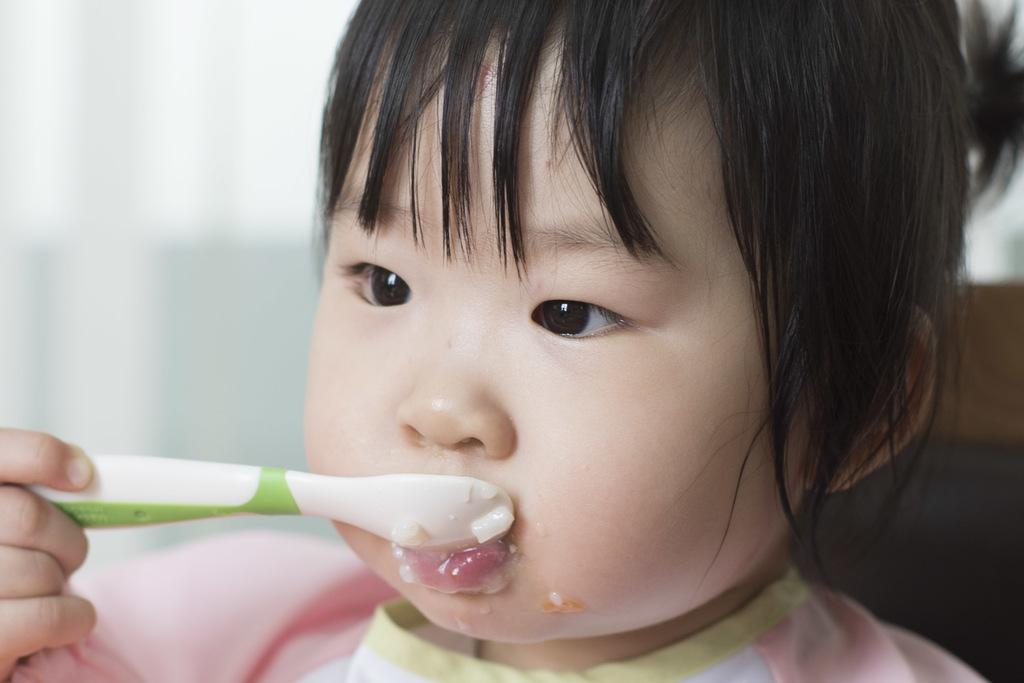What is the main subject of the image? There is a baby in the image. What is the baby doing in the image? The baby is eating food. What is the baby using to eat the food? The baby is holding a spoon in her hand. What can be seen in the background of the image? There is a wall visible in the background of the image. What type of current is flowing through the baby's hair in the image? There is no current present in the image; the baby's hair is not shown to be affected by any current. 